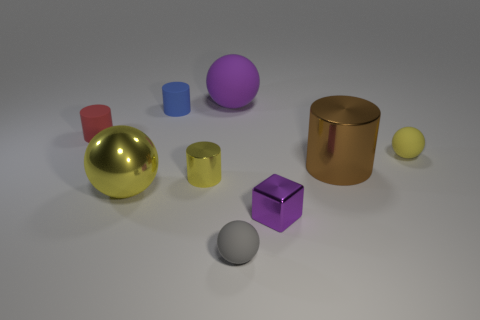There is a yellow sphere that is the same size as the brown metallic thing; what material is it?
Provide a short and direct response. Metal. How big is the ball behind the tiny matte ball that is behind the big object in front of the brown object?
Provide a succinct answer. Large. There is a big metal object that is left of the small blue rubber thing; is it the same color as the small sphere behind the metallic sphere?
Your answer should be very brief. Yes. How many blue objects are tiny blocks or shiny balls?
Your answer should be very brief. 0. How many brown matte balls have the same size as the blue rubber object?
Make the answer very short. 0. Is the tiny yellow object on the right side of the big matte object made of the same material as the large purple thing?
Provide a short and direct response. Yes. Are there any purple objects that are behind the sphere to the right of the tiny gray thing?
Your answer should be compact. Yes. There is a small yellow object that is the same shape as the large purple object; what material is it?
Give a very brief answer. Rubber. Is the number of big objects that are on the right side of the small gray rubber ball greater than the number of small yellow shiny objects that are right of the large rubber ball?
Provide a succinct answer. Yes. There is a tiny blue object that is the same material as the red cylinder; what is its shape?
Your answer should be compact. Cylinder. 